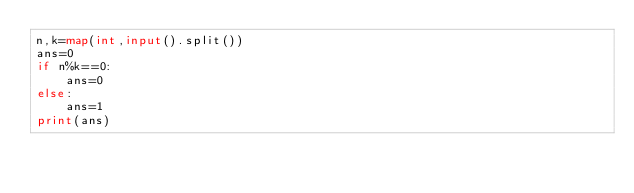<code> <loc_0><loc_0><loc_500><loc_500><_Python_>n,k=map(int,input().split())
ans=0
if n%k==0:
	ans=0
else:
	ans=1
print(ans)</code> 